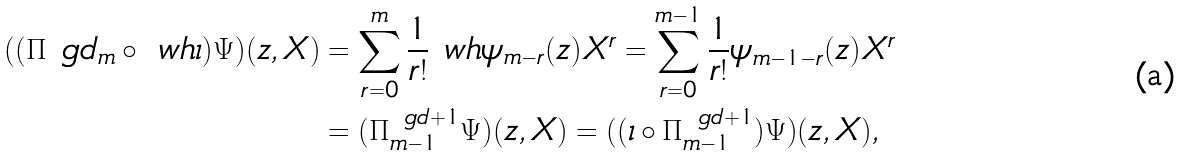<formula> <loc_0><loc_0><loc_500><loc_500>( ( \Pi ^ { \ } g d _ { m } \circ \ w h { \iota } ) \Psi ) ( z , X ) & = \sum ^ { m } _ { r = 0 } \frac { 1 } { r ! } \ w h { \psi } _ { m - r } ( z ) X ^ { r } = \sum ^ { m - 1 } _ { r = 0 } \frac { 1 } { r ! } \psi _ { m - 1 - r } ( z ) X ^ { r } \\ & = ( \Pi ^ { \ g d + 1 } _ { m - 1 } \Psi ) ( z , X ) = ( ( \iota \circ \Pi ^ { \ g d + 1 } _ { m - 1 } ) \Psi ) ( z , X ) ,</formula> 